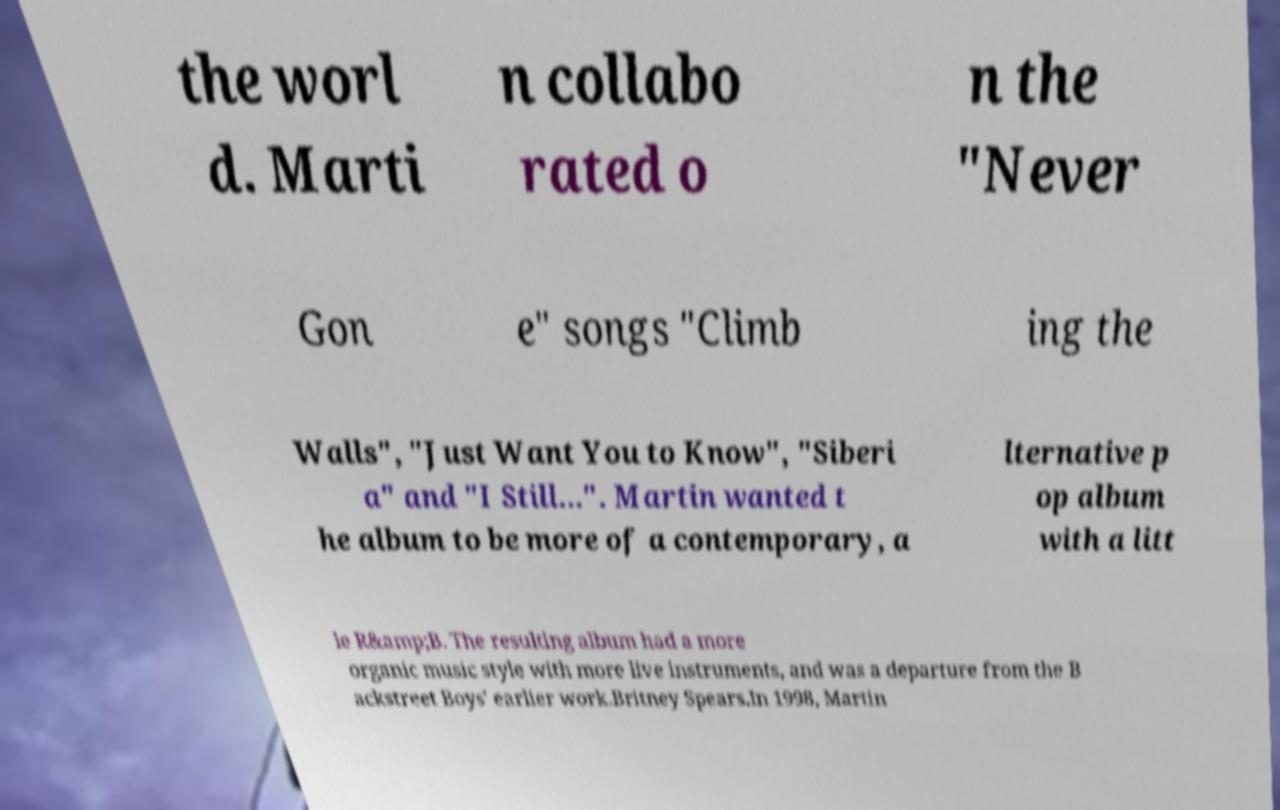There's text embedded in this image that I need extracted. Can you transcribe it verbatim? the worl d. Marti n collabo rated o n the "Never Gon e" songs "Climb ing the Walls", "Just Want You to Know", "Siberi a" and "I Still...". Martin wanted t he album to be more of a contemporary, a lternative p op album with a litt le R&amp;B. The resulting album had a more organic music style with more live instruments, and was a departure from the B ackstreet Boys' earlier work.Britney Spears.In 1998, Martin 